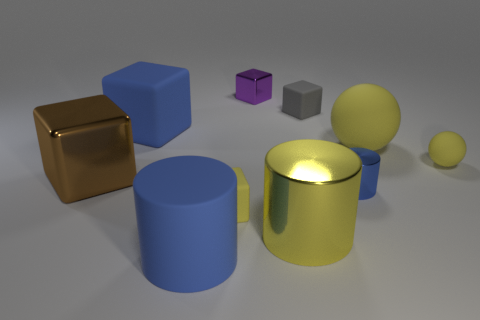Subtract all gray blocks. How many blocks are left? 4 Add 6 small matte spheres. How many small matte spheres are left? 7 Add 7 small purple blocks. How many small purple blocks exist? 8 Subtract all yellow cylinders. How many cylinders are left? 2 Subtract 1 yellow spheres. How many objects are left? 9 Subtract all cylinders. How many objects are left? 7 Subtract 1 cylinders. How many cylinders are left? 2 Subtract all green blocks. Subtract all cyan balls. How many blocks are left? 5 Subtract all gray balls. How many purple cubes are left? 1 Subtract all yellow spheres. Subtract all big yellow rubber objects. How many objects are left? 7 